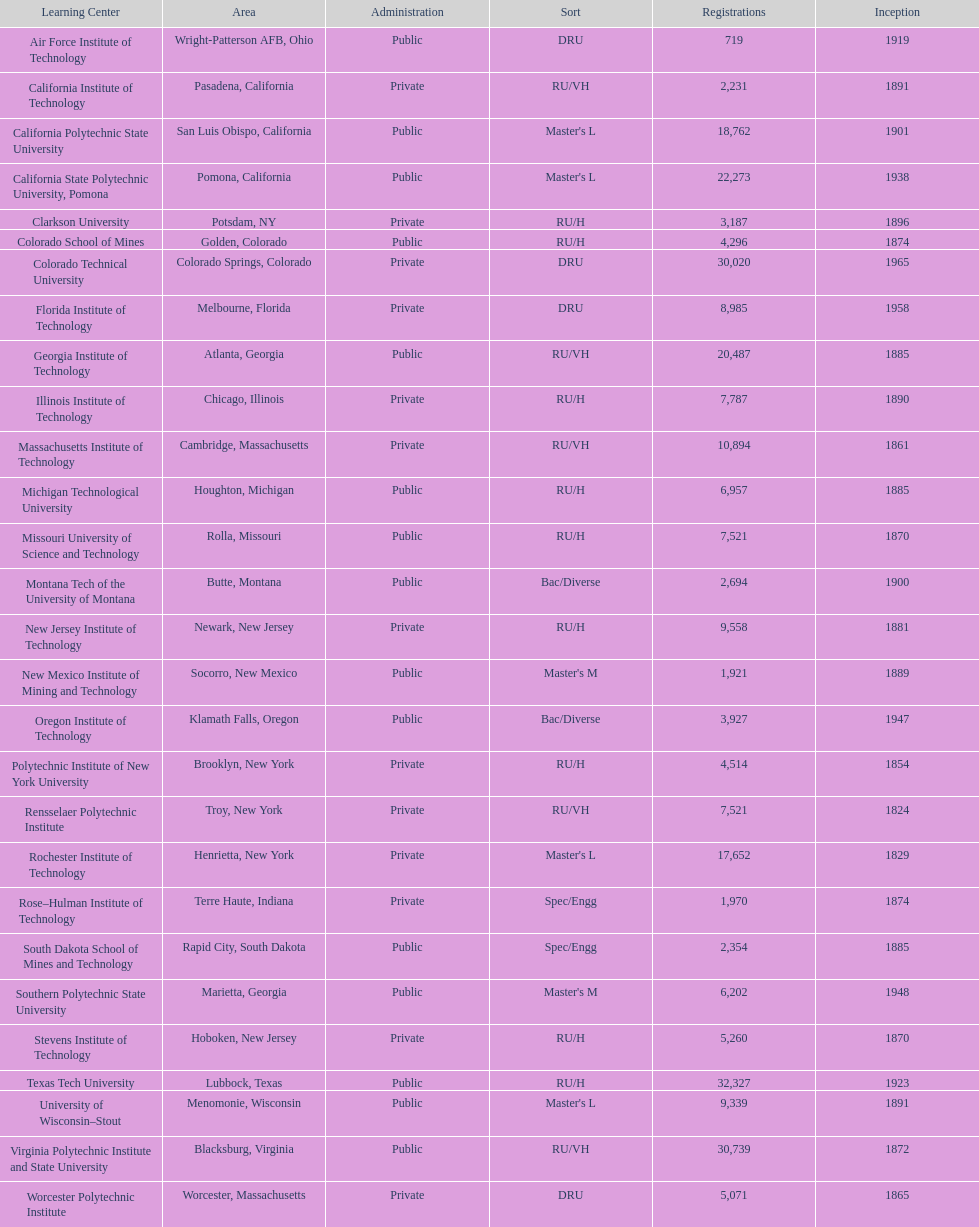Which school had the largest enrollment? Texas Tech University. 